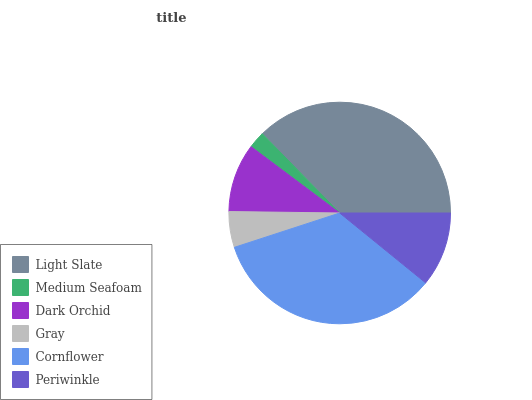Is Medium Seafoam the minimum?
Answer yes or no. Yes. Is Light Slate the maximum?
Answer yes or no. Yes. Is Dark Orchid the minimum?
Answer yes or no. No. Is Dark Orchid the maximum?
Answer yes or no. No. Is Dark Orchid greater than Medium Seafoam?
Answer yes or no. Yes. Is Medium Seafoam less than Dark Orchid?
Answer yes or no. Yes. Is Medium Seafoam greater than Dark Orchid?
Answer yes or no. No. Is Dark Orchid less than Medium Seafoam?
Answer yes or no. No. Is Periwinkle the high median?
Answer yes or no. Yes. Is Dark Orchid the low median?
Answer yes or no. Yes. Is Medium Seafoam the high median?
Answer yes or no. No. Is Periwinkle the low median?
Answer yes or no. No. 